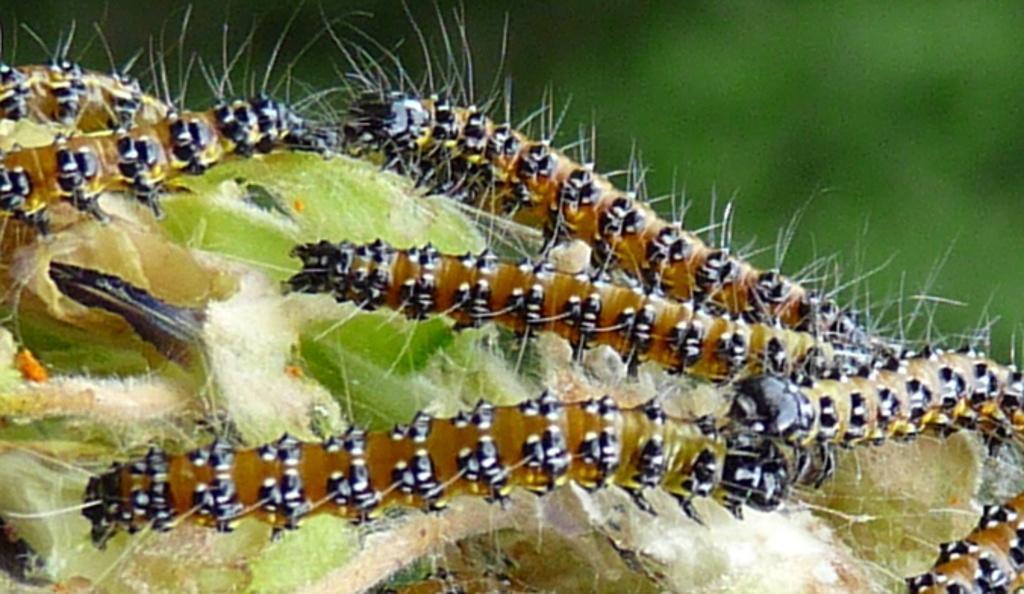Please provide a concise description of this image. In this picture we can see caterpillars in the front, there is a blurry background. 